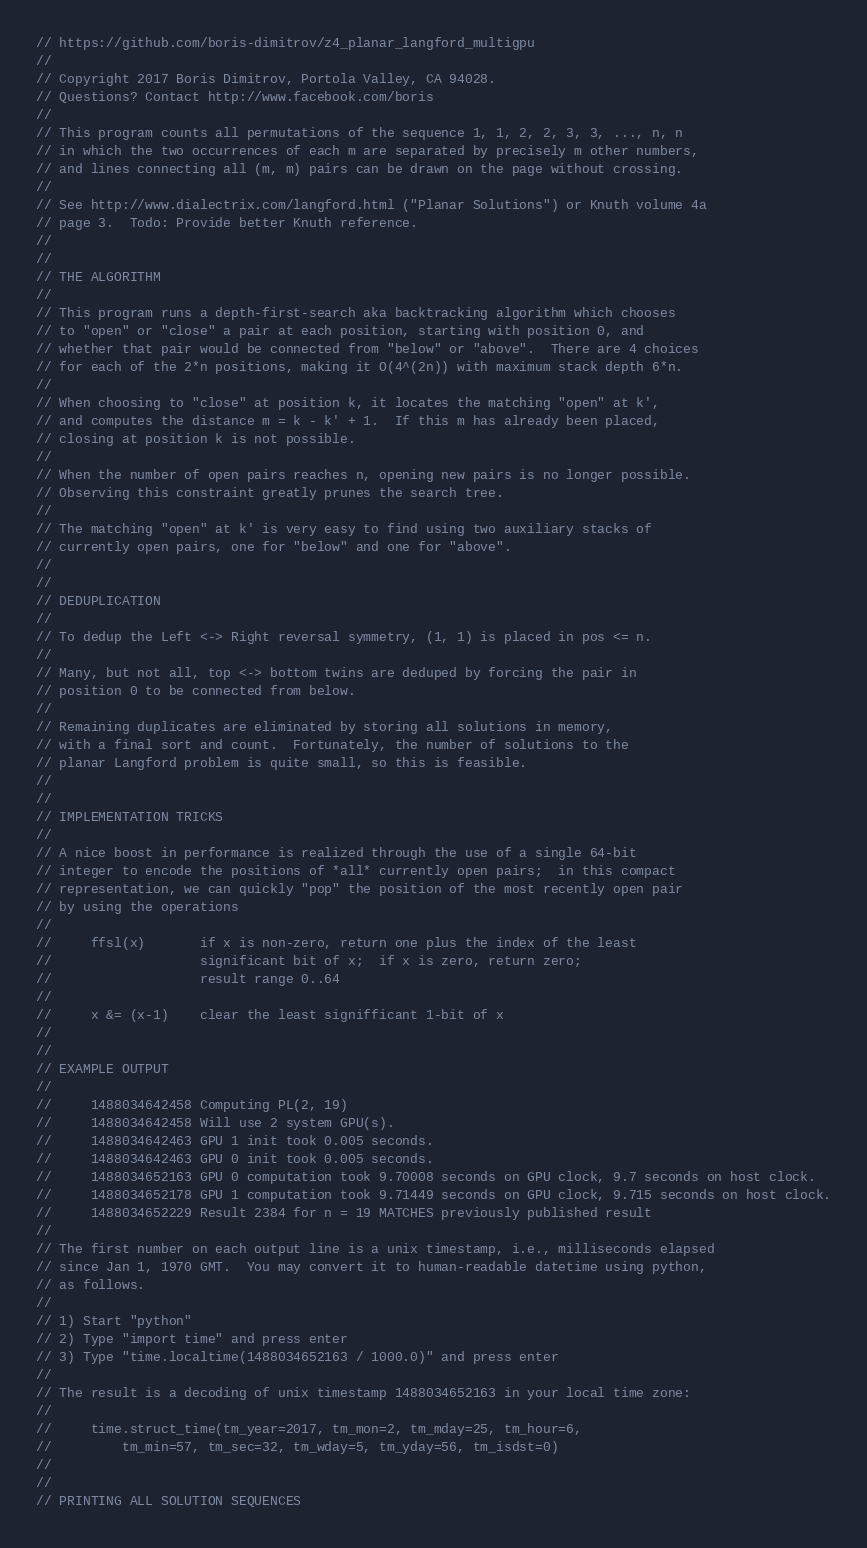<code> <loc_0><loc_0><loc_500><loc_500><_Cuda_>// https://github.com/boris-dimitrov/z4_planar_langford_multigpu
//
// Copyright 2017 Boris Dimitrov, Portola Valley, CA 94028.
// Questions? Contact http://www.facebook.com/boris
//
// This program counts all permutations of the sequence 1, 1, 2, 2, 3, 3, ..., n, n
// in which the two occurrences of each m are separated by precisely m other numbers,
// and lines connecting all (m, m) pairs can be drawn on the page without crossing.
//
// See http://www.dialectrix.com/langford.html ("Planar Solutions") or Knuth volume 4a
// page 3.  Todo: Provide better Knuth reference.
//
//
// THE ALGORITHM
//
// This program runs a depth-first-search aka backtracking algorithm which chooses
// to "open" or "close" a pair at each position, starting with position 0, and
// whether that pair would be connected from "below" or "above".  There are 4 choices
// for each of the 2*n positions, making it O(4^(2n)) with maximum stack depth 6*n.
//
// When choosing to "close" at position k, it locates the matching "open" at k',
// and computes the distance m = k - k' + 1.  If this m has already been placed,
// closing at position k is not possible.
//
// When the number of open pairs reaches n, opening new pairs is no longer possible.
// Observing this constraint greatly prunes the search tree.
//
// The matching "open" at k' is very easy to find using two auxiliary stacks of
// currently open pairs, one for "below" and one for "above".
//
//
// DEDUPLICATION
//
// To dedup the Left <-> Right reversal symmetry, (1, 1) is placed in pos <= n.
//
// Many, but not all, top <-> bottom twins are deduped by forcing the pair in
// position 0 to be connected from below.
//
// Remaining duplicates are eliminated by storing all solutions in memory,
// with a final sort and count.  Fortunately, the number of solutions to the
// planar Langford problem is quite small, so this is feasible.
//
//
// IMPLEMENTATION TRICKS
//
// A nice boost in performance is realized through the use of a single 64-bit
// integer to encode the positions of *all* currently open pairs;  in this compact
// representation, we can quickly "pop" the position of the most recently open pair
// by using the operations
//
//     ffsl(x)       if x is non-zero, return one plus the index of the least
//                   significant bit of x;  if x is zero, return zero;
//                   result range 0..64
//
//     x &= (x-1)    clear the least signifficant 1-bit of x
//
//
// EXAMPLE OUTPUT
//
//     1488034642458 Computing PL(2, 19)
//     1488034642458 Will use 2 system GPU(s).
//     1488034642463 GPU 1 init took 0.005 seconds.
//     1488034642463 GPU 0 init took 0.005 seconds.
//     1488034652163 GPU 0 computation took 9.70008 seconds on GPU clock, 9.7 seconds on host clock.
//     1488034652178 GPU 1 computation took 9.71449 seconds on GPU clock, 9.715 seconds on host clock.
//     1488034652229 Result 2384 for n = 19 MATCHES previously published result
//
// The first number on each output line is a unix timestamp, i.e., milliseconds elapsed
// since Jan 1, 1970 GMT.  You may convert it to human-readable datetime using python,
// as follows.
//
// 1) Start "python"
// 2) Type "import time" and press enter
// 3) Type "time.localtime(1488034652163 / 1000.0)" and press enter
//
// The result is a decoding of unix timestamp 1488034652163 in your local time zone:
//
//     time.struct_time(tm_year=2017, tm_mon=2, tm_mday=25, tm_hour=6,
//         tm_min=57, tm_sec=32, tm_wday=5, tm_yday=56, tm_isdst=0)
//
//
// PRINTING ALL SOLUTION SEQUENCES</code> 